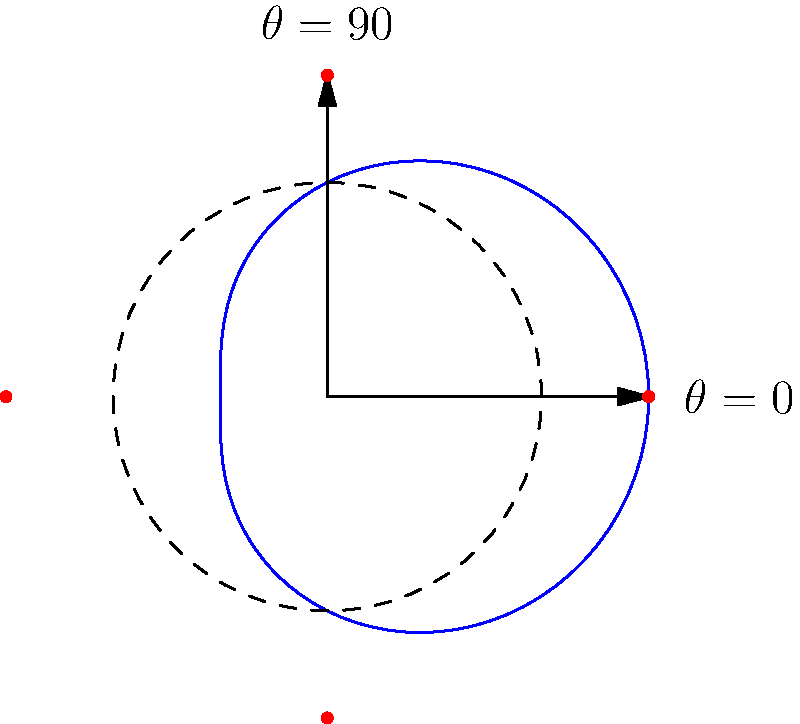As a chiropractor, you're analyzing the range of motion of a patient's shoulder joint using a polar coordinate system. The blue curve represents the path of the patient's hand during rotation, described by the equation $r = 2 + \cos(\theta)$. What is the maximum rotation angle $\theta$ (in degrees) where the distance from the shoulder joint (origin) to the hand is at its minimum? To solve this problem, we need to follow these steps:

1) The distance from the shoulder joint to the hand is given by the equation $r = 2 + \cos(\theta)$.

2) We need to find the minimum value of $r$, which will occur when $\cos(\theta)$ is at its minimum.

3) We know that the minimum value of cosine is -1, which occurs at $\theta = 180°$ or $\pi$ radians.

4) To verify, let's calculate $r$ at $\theta = 180°$:
   $r = 2 + \cos(180°) = 2 + (-1) = 1$

5) This is indeed the minimum value of $r$, as $r$ will always be greater than or equal to 1 (since 2 - 1 = 1).

6) Therefore, the maximum rotation angle where the distance is at its minimum is 180°.
Answer: 180° 